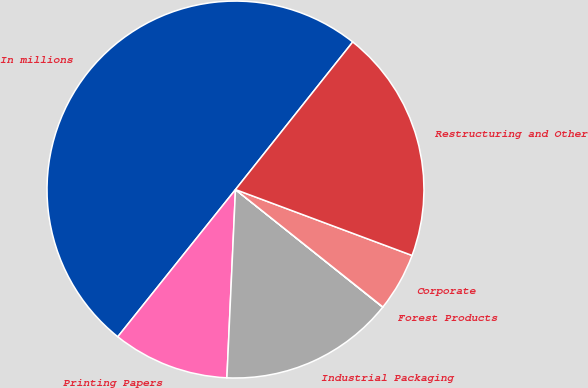<chart> <loc_0><loc_0><loc_500><loc_500><pie_chart><fcel>In millions<fcel>Printing Papers<fcel>Industrial Packaging<fcel>Forest Products<fcel>Corporate<fcel>Restructuring and Other<nl><fcel>49.95%<fcel>10.01%<fcel>15.0%<fcel>0.02%<fcel>5.02%<fcel>20.0%<nl></chart> 